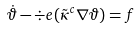Convert formula to latex. <formula><loc_0><loc_0><loc_500><loc_500>\dot { \vartheta } - \div e ( \tilde { \kappa } ^ { c } \nabla \vartheta ) = f</formula> 